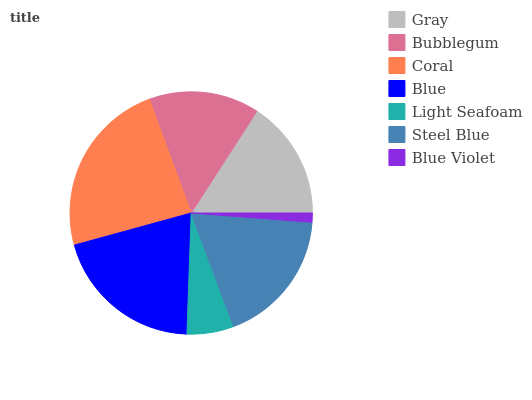Is Blue Violet the minimum?
Answer yes or no. Yes. Is Coral the maximum?
Answer yes or no. Yes. Is Bubblegum the minimum?
Answer yes or no. No. Is Bubblegum the maximum?
Answer yes or no. No. Is Gray greater than Bubblegum?
Answer yes or no. Yes. Is Bubblegum less than Gray?
Answer yes or no. Yes. Is Bubblegum greater than Gray?
Answer yes or no. No. Is Gray less than Bubblegum?
Answer yes or no. No. Is Gray the high median?
Answer yes or no. Yes. Is Gray the low median?
Answer yes or no. Yes. Is Steel Blue the high median?
Answer yes or no. No. Is Blue the low median?
Answer yes or no. No. 